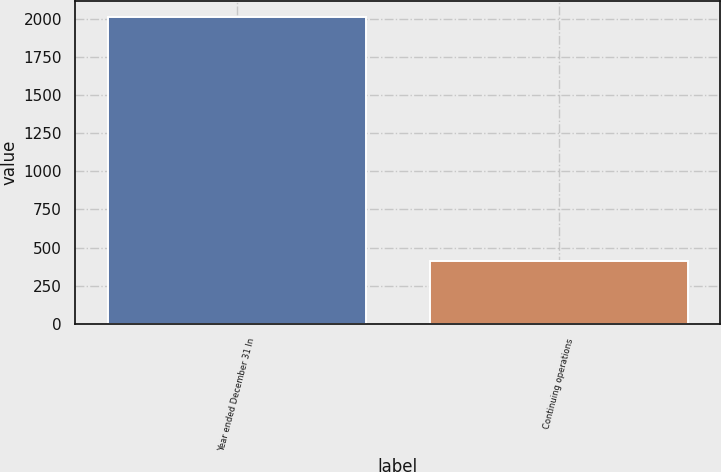Convert chart to OTSL. <chart><loc_0><loc_0><loc_500><loc_500><bar_chart><fcel>Year ended December 31 In<fcel>Continuing operations<nl><fcel>2013<fcel>412<nl></chart> 